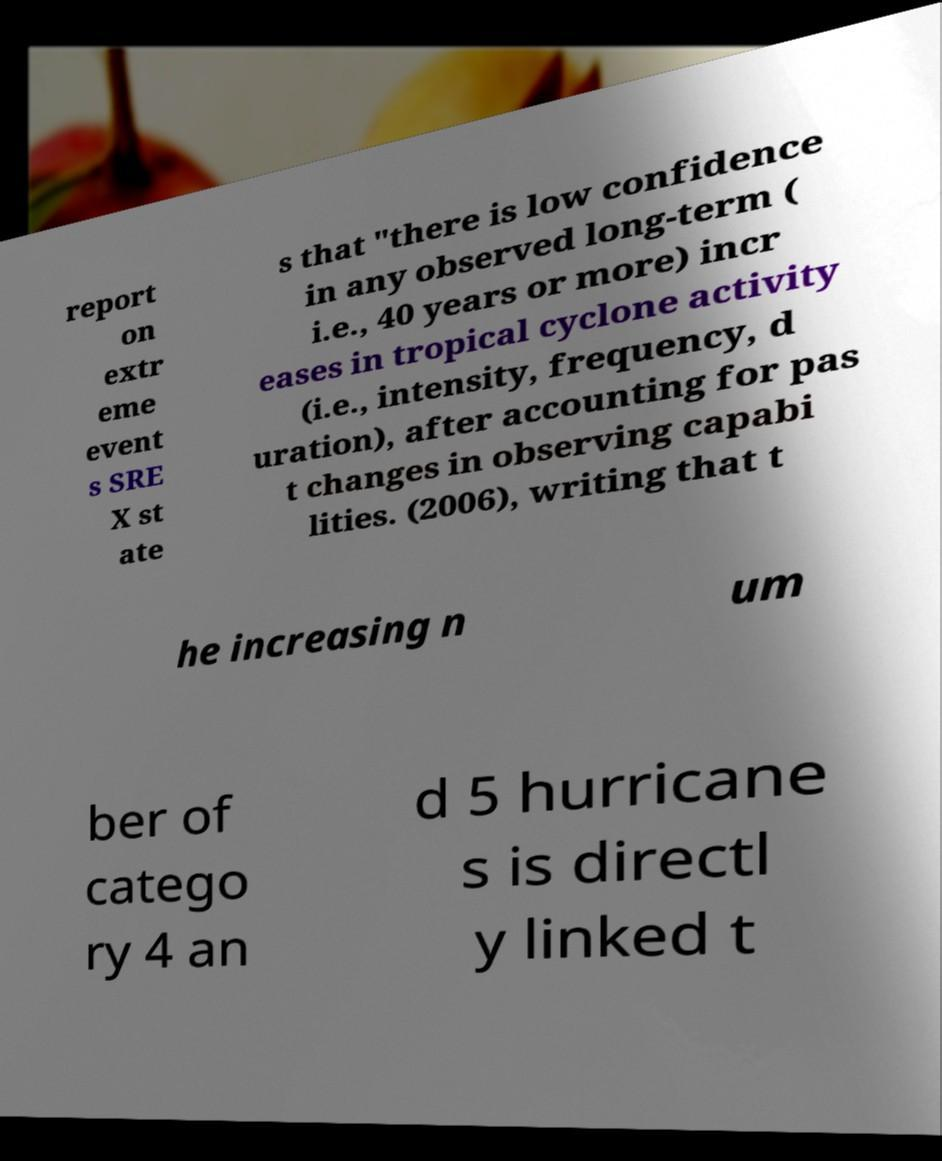Please read and relay the text visible in this image. What does it say? report on extr eme event s SRE X st ate s that "there is low confidence in any observed long-term ( i.e., 40 years or more) incr eases in tropical cyclone activity (i.e., intensity, frequency, d uration), after accounting for pas t changes in observing capabi lities. (2006), writing that t he increasing n um ber of catego ry 4 an d 5 hurricane s is directl y linked t 